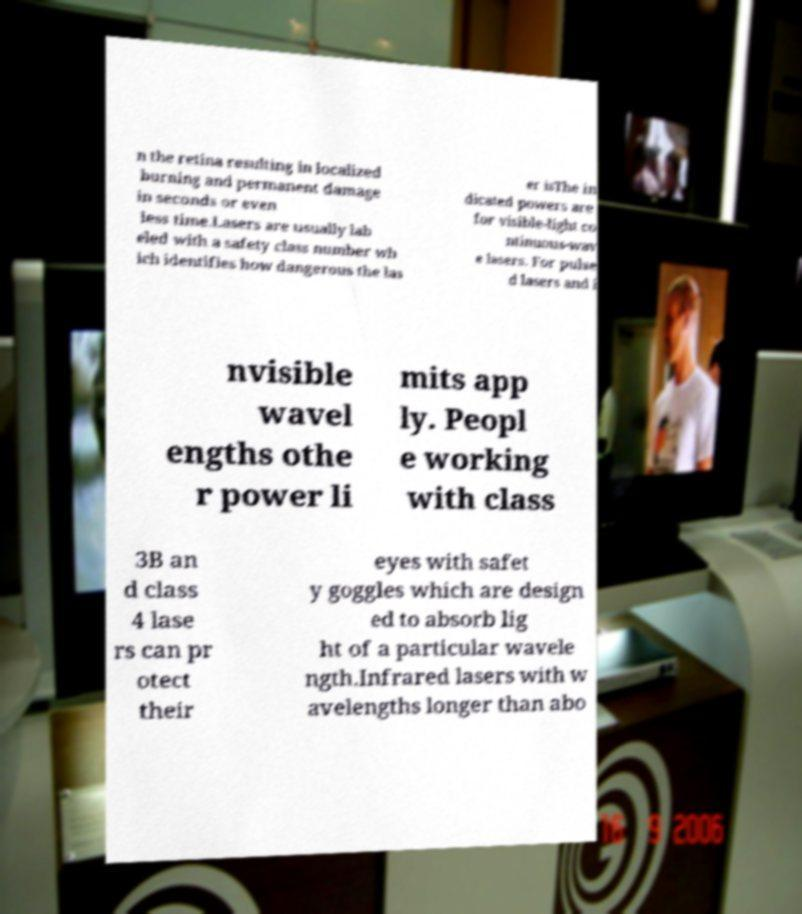What messages or text are displayed in this image? I need them in a readable, typed format. n the retina resulting in localized burning and permanent damage in seconds or even less time.Lasers are usually lab eled with a safety class number wh ich identifies how dangerous the las er isThe in dicated powers are for visible-light co ntinuous-wav e lasers. For pulse d lasers and i nvisible wavel engths othe r power li mits app ly. Peopl e working with class 3B an d class 4 lase rs can pr otect their eyes with safet y goggles which are design ed to absorb lig ht of a particular wavele ngth.Infrared lasers with w avelengths longer than abo 